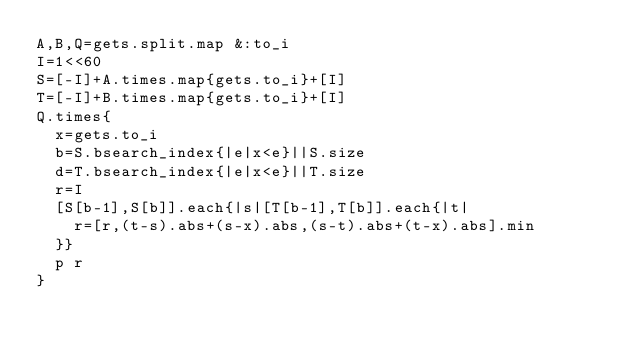Convert code to text. <code><loc_0><loc_0><loc_500><loc_500><_Ruby_>A,B,Q=gets.split.map &:to_i
I=1<<60
S=[-I]+A.times.map{gets.to_i}+[I]
T=[-I]+B.times.map{gets.to_i}+[I]
Q.times{
	x=gets.to_i
	b=S.bsearch_index{|e|x<e}||S.size
	d=T.bsearch_index{|e|x<e}||T.size
	r=I
	[S[b-1],S[b]].each{|s|[T[b-1],T[b]].each{|t|
		r=[r,(t-s).abs+(s-x).abs,(s-t).abs+(t-x).abs].min
	}}
	p r
}</code> 